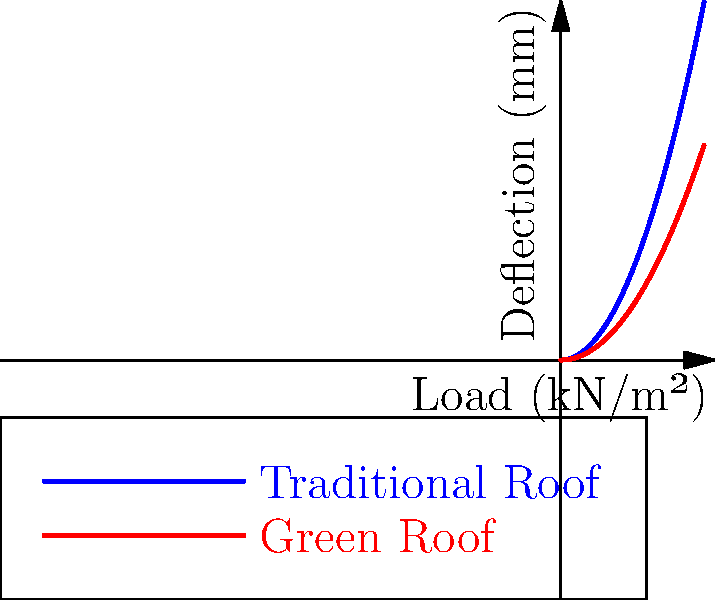The graph shows the load-deflection curves for a traditional roof and a climate-adaptive green roof system. Based on the biomechanical properties illustrated, what can be concluded about the green roof's performance under load compared to the traditional roof? To analyze the biomechanical properties of the climate-adaptive green roof system compared to the traditional roof, we need to interpret the load-deflection curves:

1. Observe the curves:
   - Blue curve represents the traditional roof
   - Red curve represents the green roof

2. Analyze the slope of the curves:
   - The slope of a load-deflection curve represents the stiffness of the structure
   - A steeper slope indicates higher stiffness (less deflection for the same load)

3. Compare the curves:
   - The green roof curve (red) has a lower slope than the traditional roof curve (blue)
   - For any given load, the green roof shows less deflection

4. Interpret the results:
   - Lower deflection under the same load indicates higher stiffness
   - Higher stiffness suggests better load distribution and structural integrity

5. Consider the implications for climate adaptation:
   - Improved load distribution can help manage additional weight from increased precipitation or snow loads due to climate change
   - Enhanced structural integrity can better withstand extreme weather events

6. Conclusion:
   The climate-adaptive green roof system demonstrates superior stiffness and load-bearing capacity compared to the traditional roof, making it more resilient to climate-related stresses.
Answer: The green roof exhibits higher stiffness and better load distribution, enhancing climate resilience. 